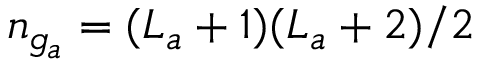<formula> <loc_0><loc_0><loc_500><loc_500>n _ { g _ { a } } = ( L _ { a } + 1 ) ( L _ { a } + 2 ) / 2</formula> 